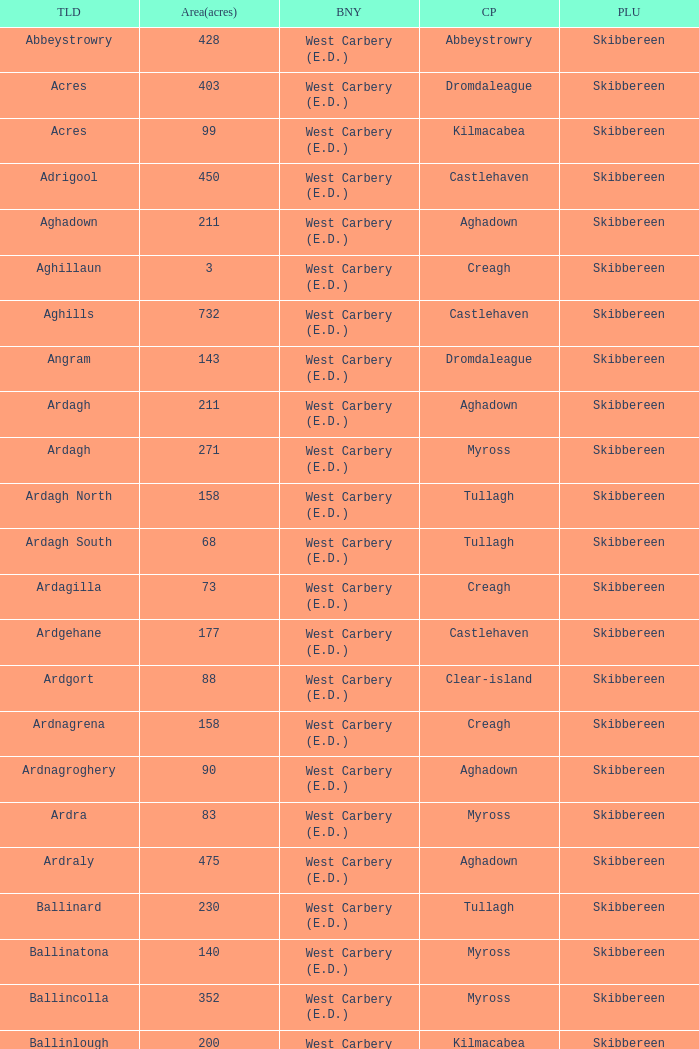What are the areas (in acres) of the Kilnahera East townland? 257.0. 